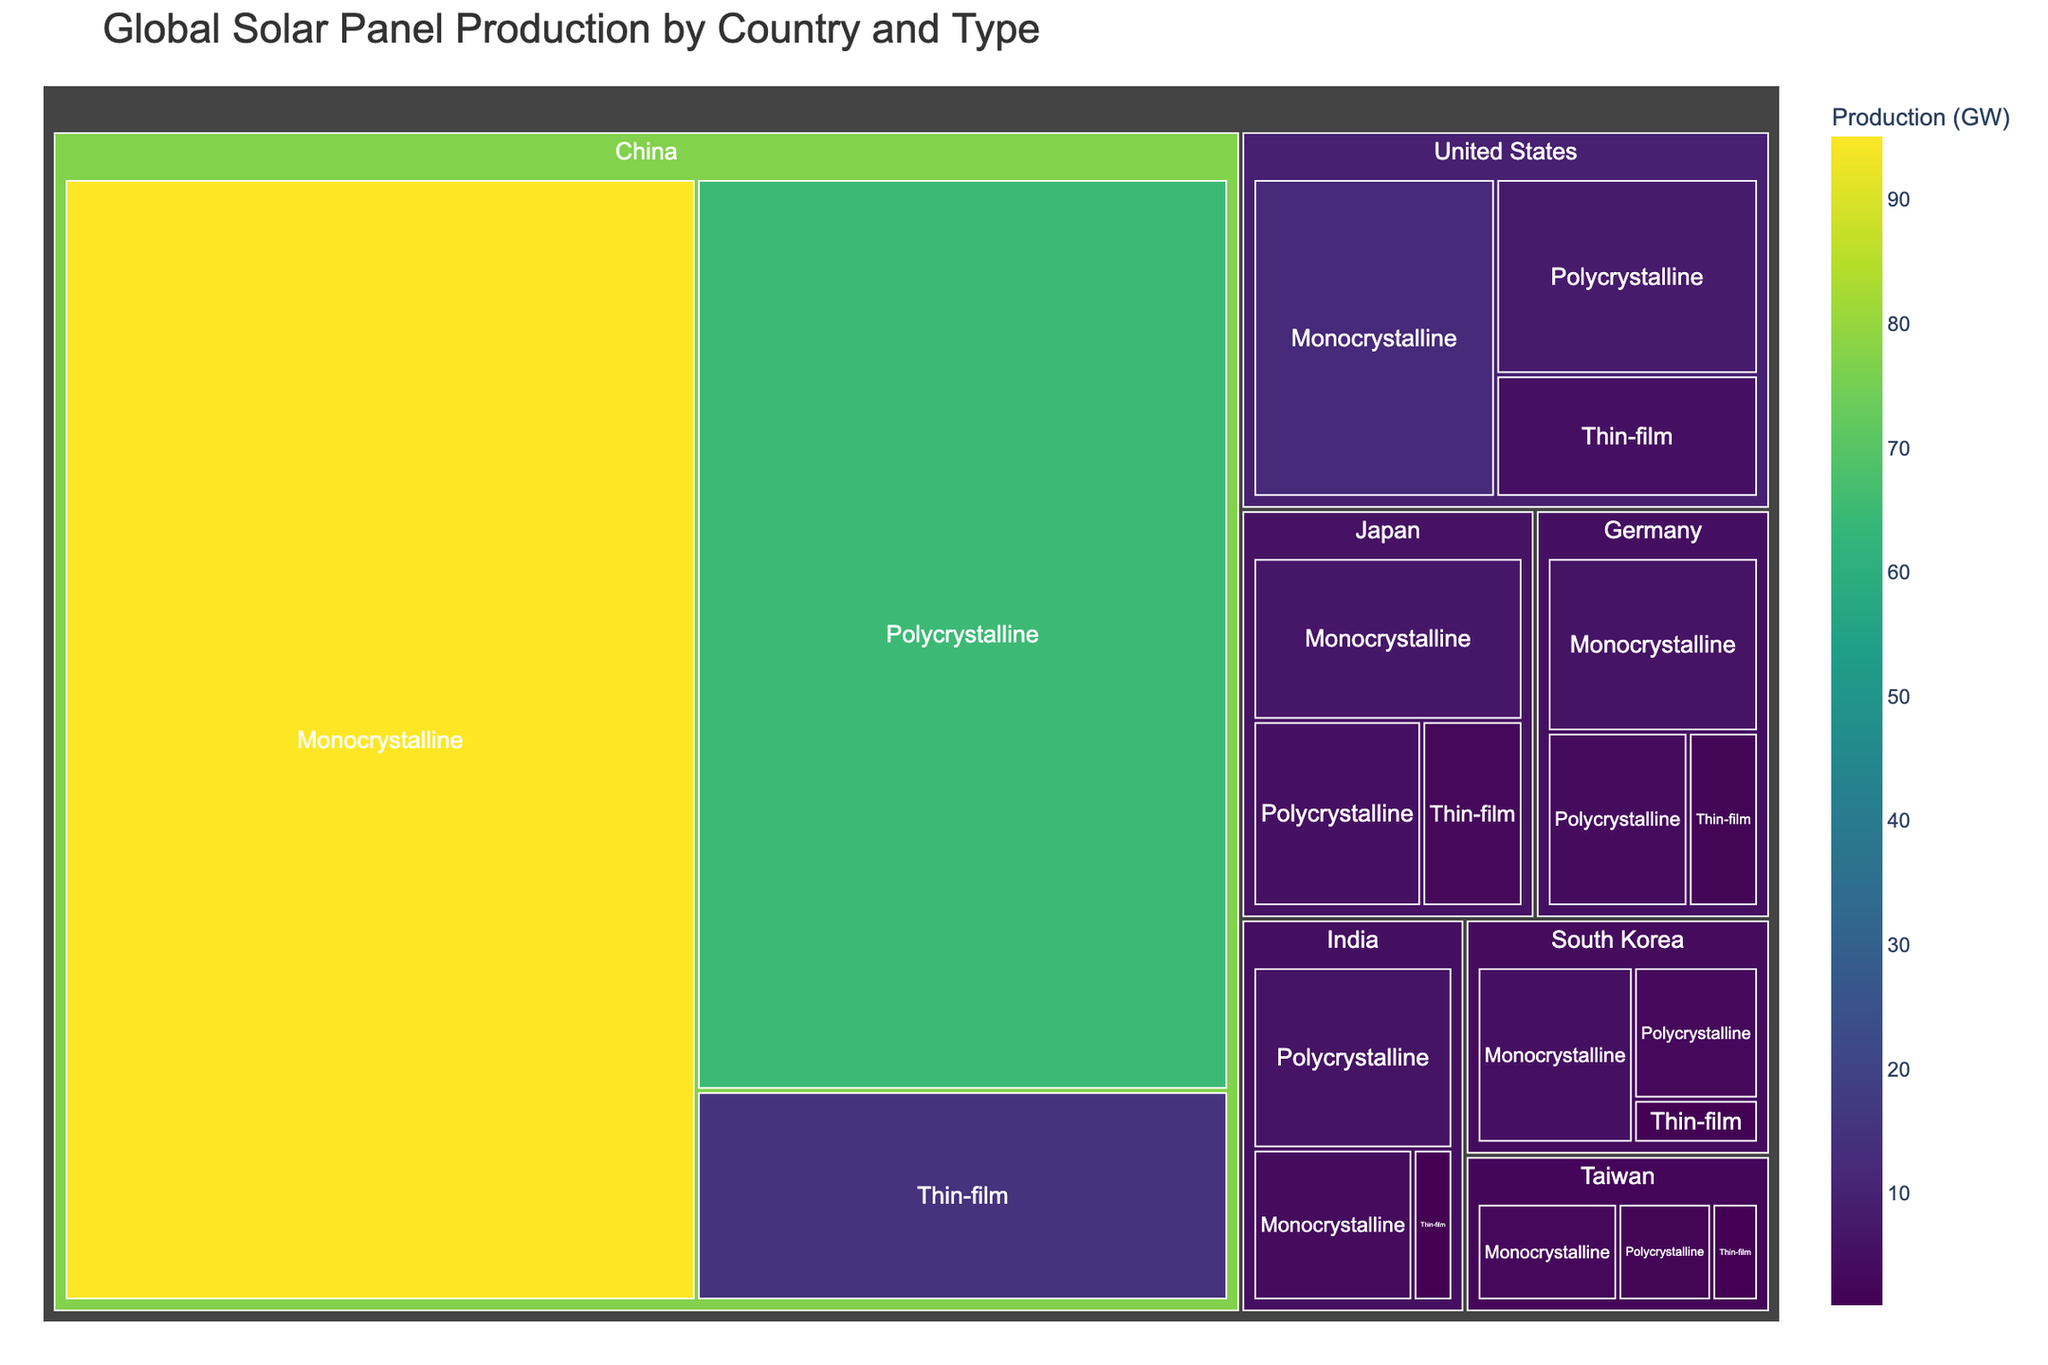What's the title of the treemap? The title of the figure is displayed prominently at the top. It indicates the subject matter of the treemap.
Answer: Global Solar Panel Production by Country and Type Which country has the highest production of Monocrystalline panels? In the figure, the largest section for Monocrystalline panels is found under the label for China.
Answer: China What's the production (in GW) of Polycrystalline panels in the United States? Look for the section corresponding to Polycrystalline panels under the United States label.
Answer: 8 GW Which country produces the least amount of Thin-film panels? Find the smallest Thin-film panel section and identify the associated country. There are equal lowest counts.
Answer: South Korea, India, and Taiwan How does the Monocrystalline production in Germany compare to Japan? Compare the sizes of the Monocrystalline sections under Germany and Japan.
Answer: Germany produces 6 GW, Japan produces 7 GW What is the total Polycrystalline production of China and South Korea combined? Sum the Polycrystalline production values of China and South Korea. 65 GW (China) + 3 GW (South Korea) = 68 GW.
Answer: 68 GW Which panel type has the highest production globally? The largest sections belong to Monocrystalline panels, indicating the highest overall production.
Answer: Monocrystalline What's the total production of solar panels in the United States? Sum the production values for all panel types in the United States. 12 GW + 8 GW + 5 GW = 25 GW.
Answer: 25 GW How many countries are represented in the treemap? Count the number of unique countries labeled in the treemap.
Answer: 7 countries Which country has the smallest overall production, and what is its total production? Compare the total production (sum of all panel types) for each country. Taiwan has the smallest overall production: 3 GW (Monocrystalline) + 2 GW (Polycrystalline) + 1 GW (Thin-film) = 6 GW.
Answer: Taiwan, 6 GW 